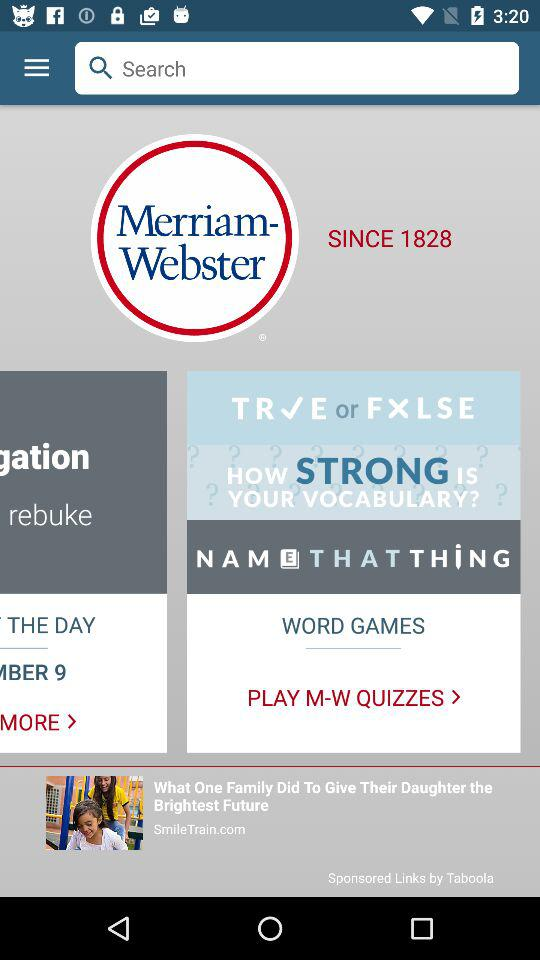What is the name of the application? The name of the application is "Merriam-Webster". 